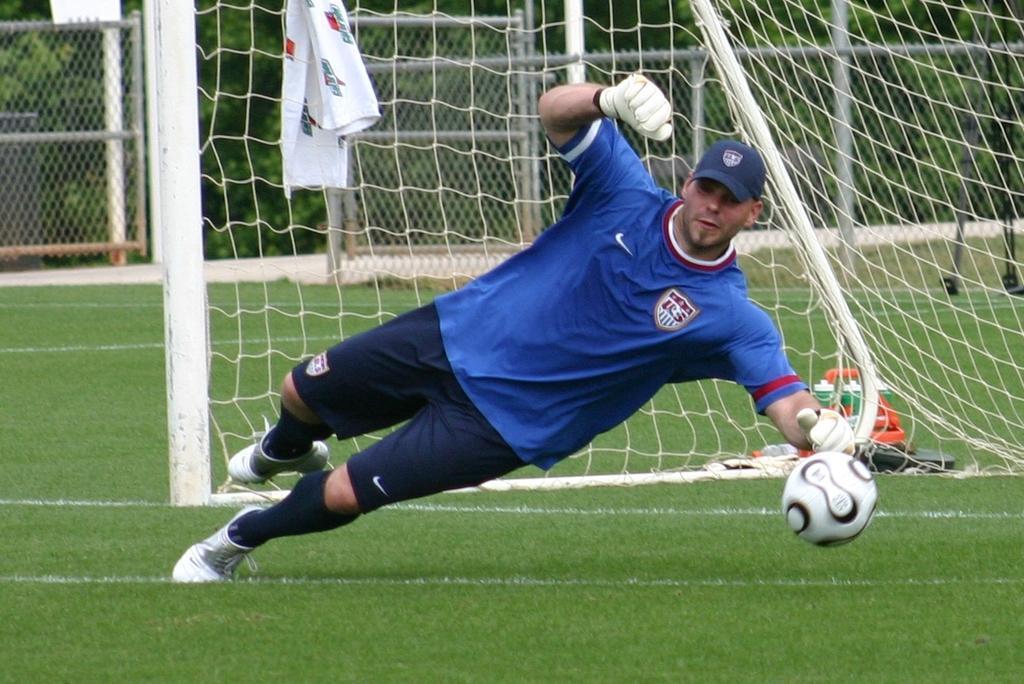Please provide a concise description of this image. In this image I can see a person wearing blue t shirt, blue short, blue hat and white shoe is jumping to catch the ball. I can see some grass and the goal post. I can see a white colored cloth. In the background I can see the metal fencing and few trees. 